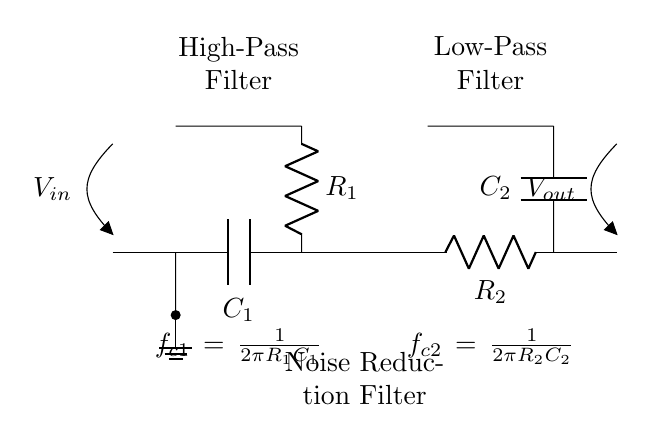What is the input voltage of the circuit? The input voltage, marked as \( V_{in} \), is the voltage supplied to the circuit from the source, as indicated at the input node.
Answer: \( V_{in} \) What are the values of the capacitors in the circuit? The circuit has two capacitors: \( C_1 \) for the high-pass filter and \( C_2 \) for the low-pass filter. The values are not specified in the diagram, but they are represented by the symbols \( C_1 \) and \( C_2 \).
Answer: \( C_1, C_2 \) Which components make up the noise reduction filter? The noise reduction filter is comprised of a high-pass filter and a low-pass filter in series, which are shown in the circuit as two separate sections.
Answer: High-pass and low-pass filter What is the cutoff frequency of the high-pass filter? The cutoff frequency for the high-pass filter is given by the formula \( f_{c1} = \frac{1}{2\pi R_1C_1} \), where \( R_1 \) and \( C_1 \) are the resistor and capacitor values for that section. This formula indicates how the frequency response of the filter behaves at a specific point.
Answer: \( \frac{1}{2\pi R_1C_1} \) What is the function of the low-pass filter in this circuit? The low-pass filter allows signals with a frequency lower than its cutoff frequency to pass through while attenuating higher frequencies, helping to reduce noise in the audio signal processed by the circuit.
Answer: Attenuates high frequencies What components are in series with the input voltage? The components in series with the input voltage consist of the capacitor \( C_1 \) and the resistor \( R_1 \) for the high-pass filter; both are connected sequentially before the output.
Answer: \( C_1, R_1 \) How many filters are included in this noise reduction configuration? This configuration includes two filters: a high-pass filter and a low-pass filter, working together to reduce noise effectively in the audio signal.
Answer: Two filters 